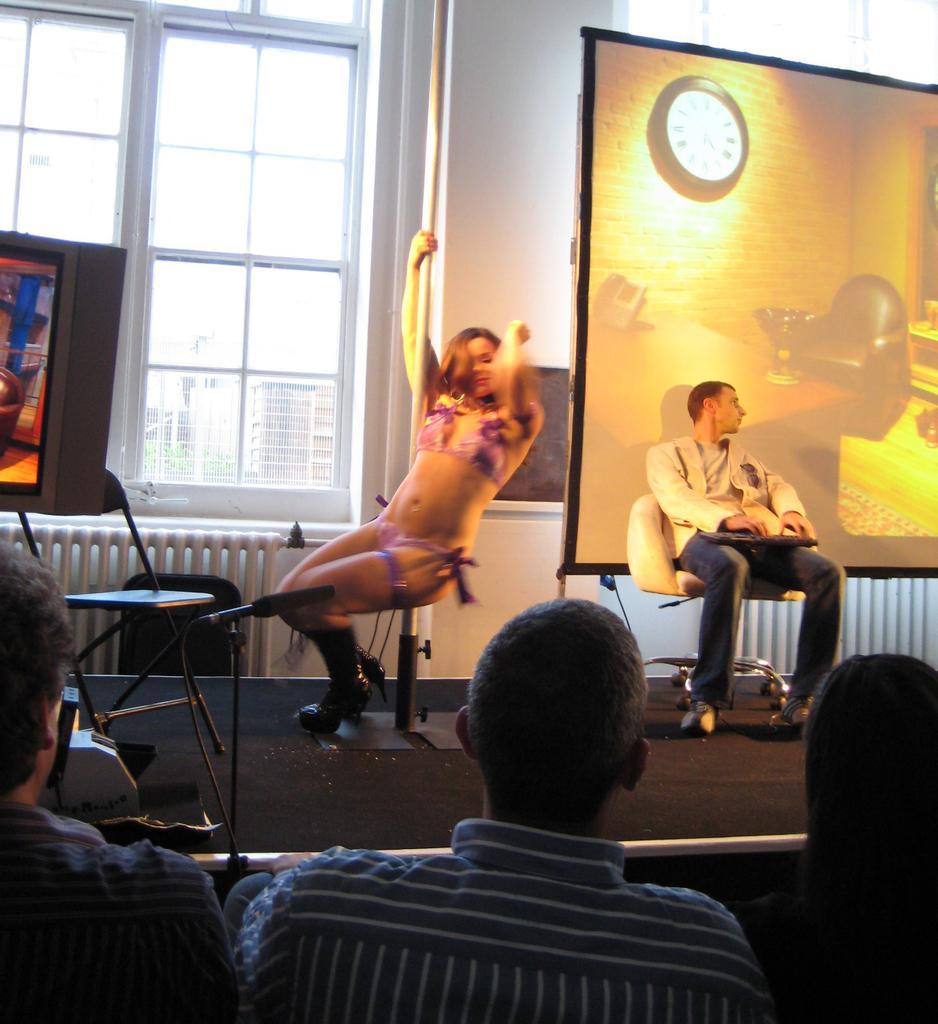In one or two sentences, can you explain what this image depicts? In this picture we can observe two persons sitting in the chairs on the stage. One of them is a woman and the other is a man. On the right side we can observe a projector display screen. There are some people sitting in the chairs in front the stage. In the background there are windows. 